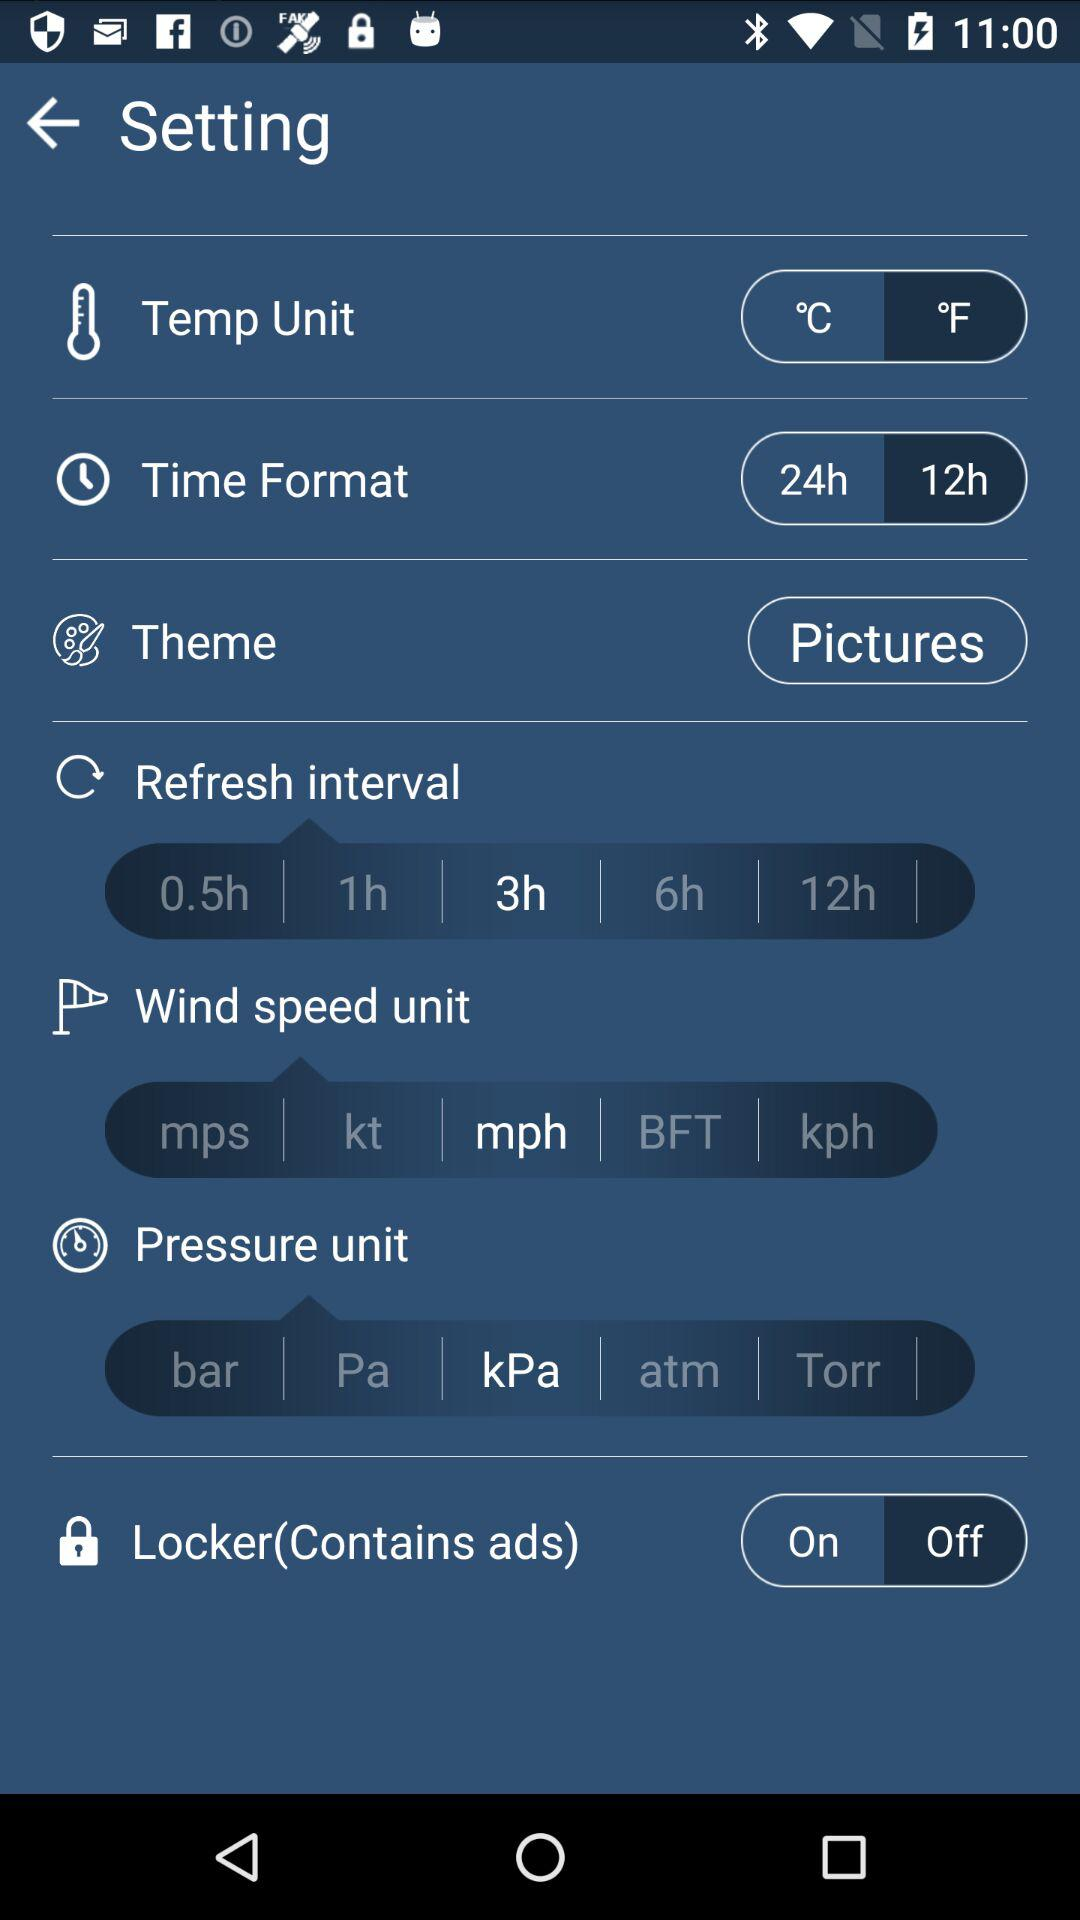What time format is selected? The selected time format is 12 hours. 